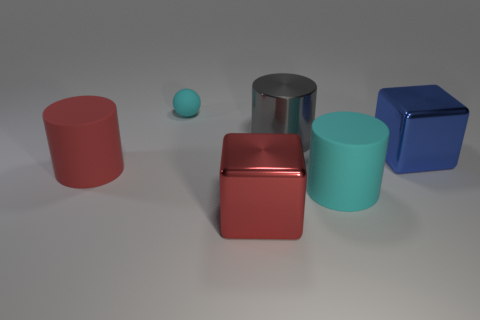Is there anything else that is the same size as the cyan matte ball?
Your answer should be compact. No. What number of red things are made of the same material as the gray cylinder?
Make the answer very short. 1. What number of blue objects have the same size as the gray cylinder?
Your response must be concise. 1. The large cylinder that is in front of the large red thing behind the cyan matte thing that is in front of the big red cylinder is made of what material?
Ensure brevity in your answer.  Rubber. How many objects are either large red cylinders or gray cylinders?
Offer a terse response. 2. What is the shape of the tiny matte object?
Your answer should be very brief. Sphere. What is the shape of the big object to the left of the matte thing behind the big metallic cylinder?
Give a very brief answer. Cylinder. Is the material of the object that is behind the gray metallic cylinder the same as the red cylinder?
Make the answer very short. Yes. What number of cyan objects are either small things or big matte things?
Provide a succinct answer. 2. Are there any rubber balls that have the same color as the tiny rubber thing?
Your answer should be very brief. No. 